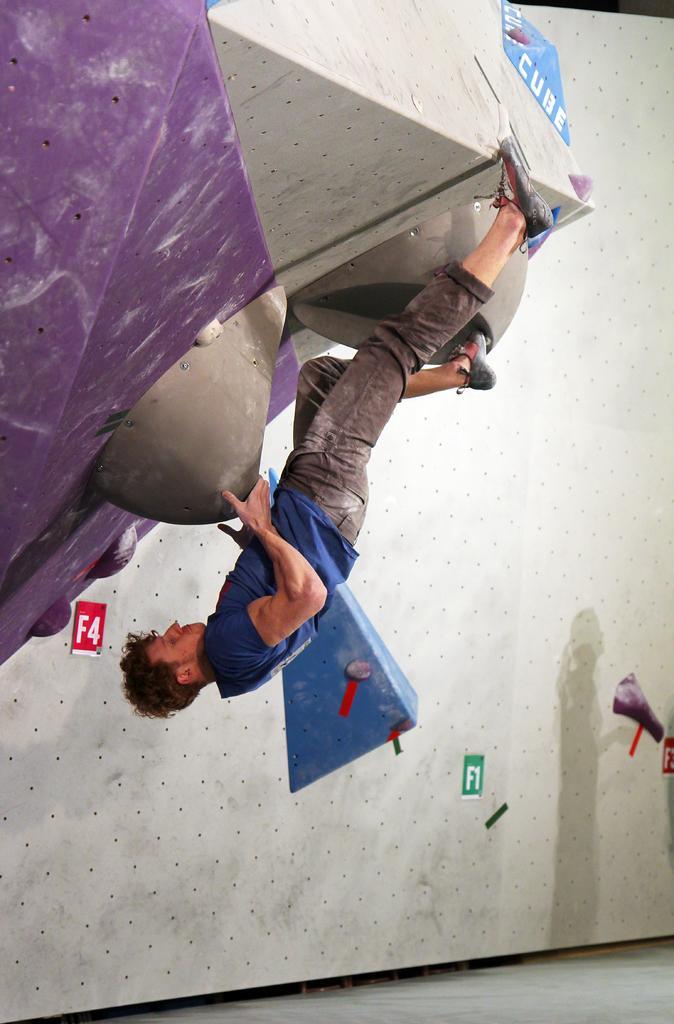Please provide a concise description of this image. In this image I can see a man. I can see he is wearing jeans, blue colour t shirt and shoes. I can also see few boards and on these words I can see something is written. 